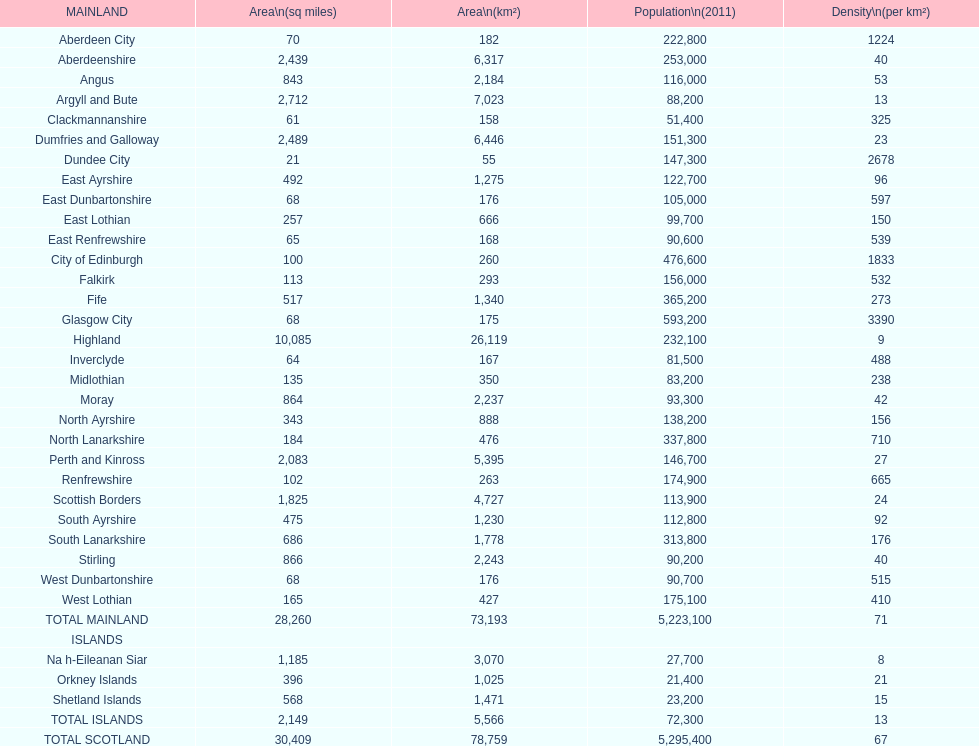If you were to organize the sites from the smallest to largest space, which one would be the initial one on the list? Dundee City. 